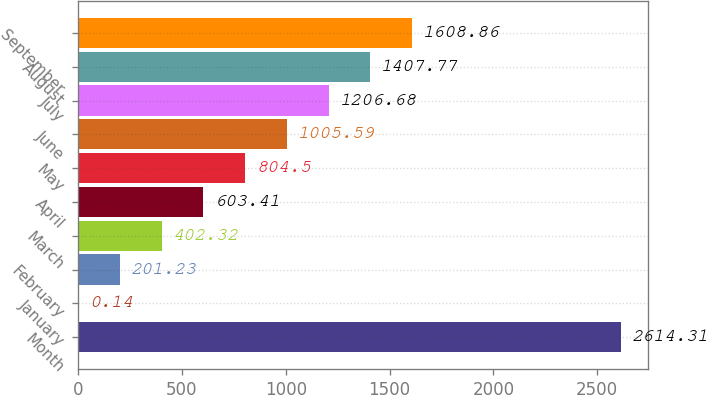Convert chart. <chart><loc_0><loc_0><loc_500><loc_500><bar_chart><fcel>Month<fcel>January<fcel>February<fcel>March<fcel>April<fcel>May<fcel>June<fcel>July<fcel>August<fcel>September<nl><fcel>2614.31<fcel>0.14<fcel>201.23<fcel>402.32<fcel>603.41<fcel>804.5<fcel>1005.59<fcel>1206.68<fcel>1407.77<fcel>1608.86<nl></chart> 